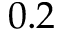Convert formula to latex. <formula><loc_0><loc_0><loc_500><loc_500>0 . 2</formula> 